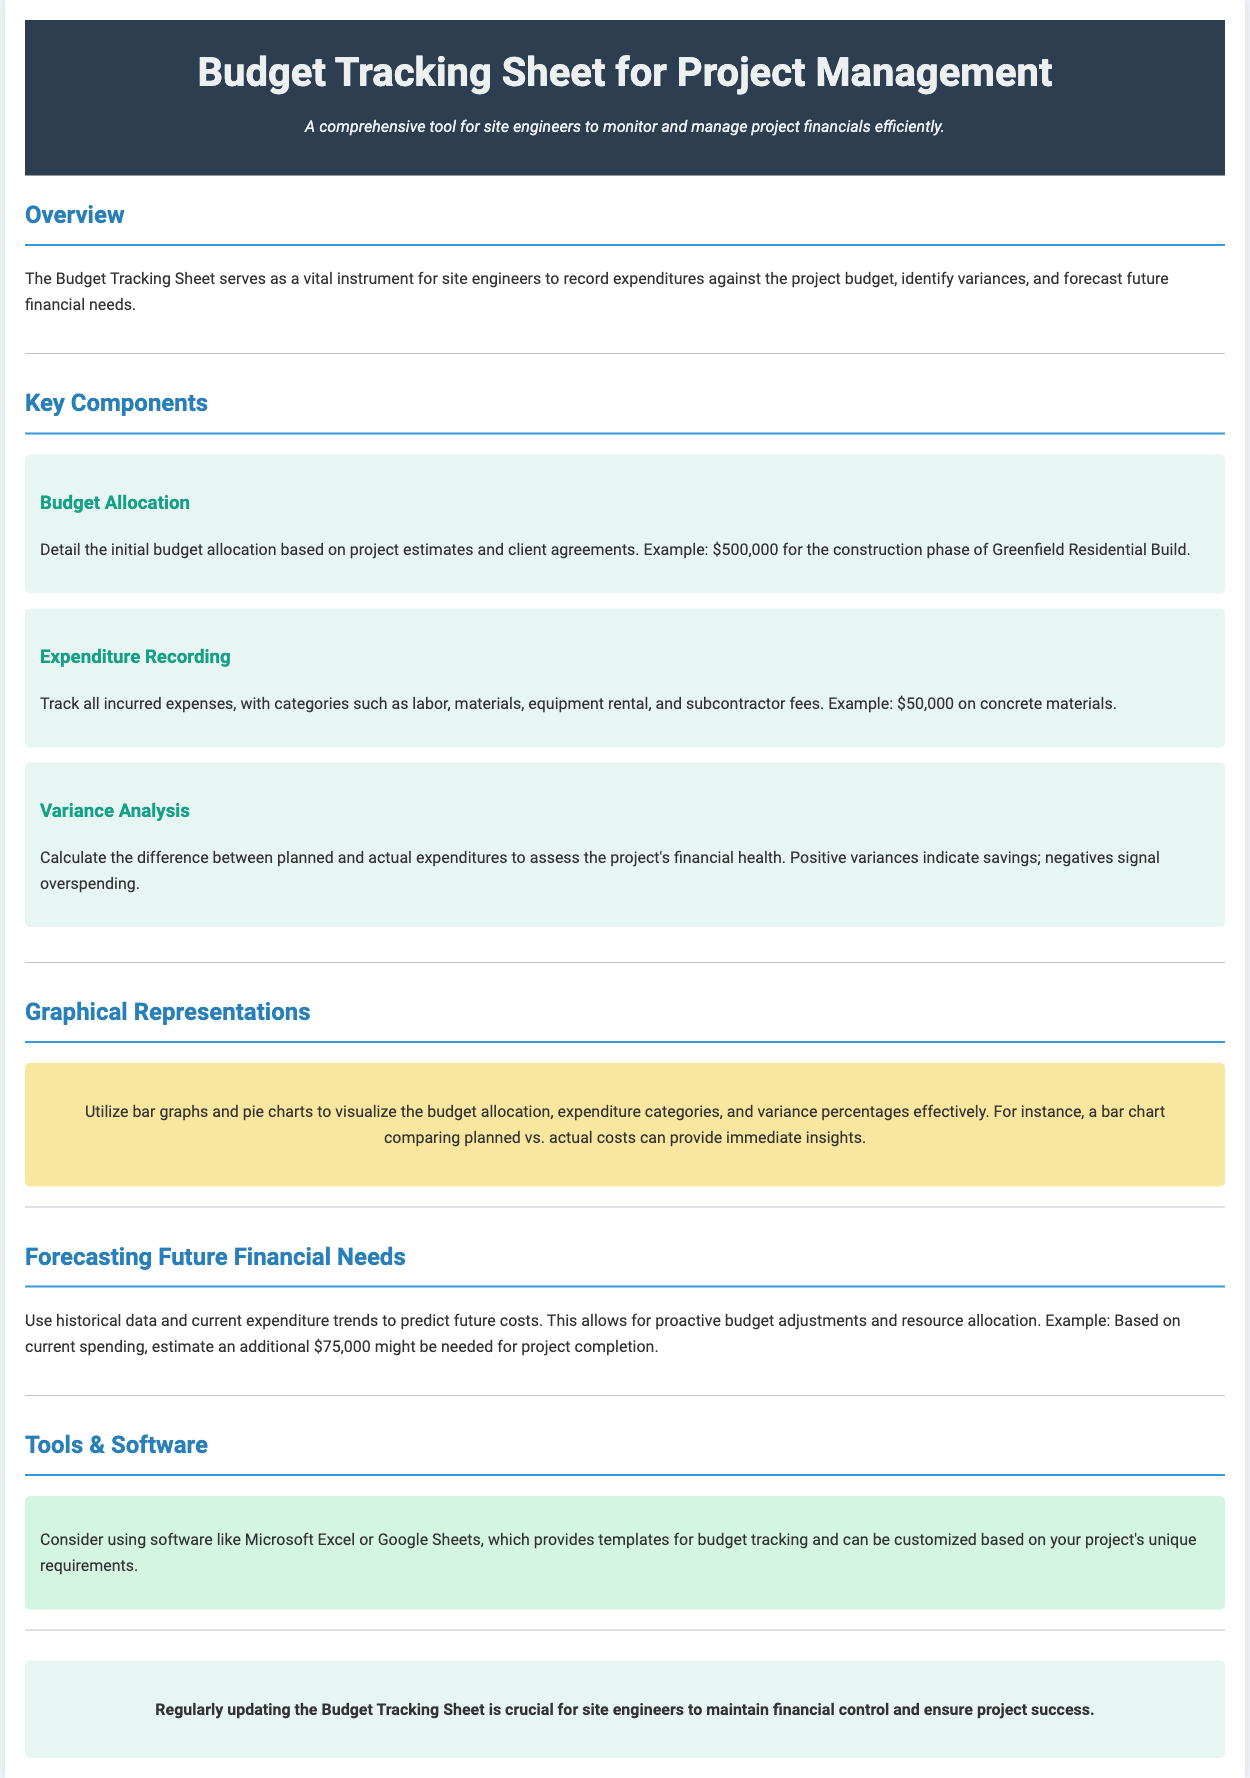What is the title of the document? The title is presented in the header of the document, clearly stated as "Budget Tracking Sheet for Project Management."
Answer: Budget Tracking Sheet for Project Management What is the initial budget allocation mentioned? The document provides an example of the initial budget allocation as $500,000 for the construction phase of a specific project.
Answer: $500,000 What type of expenses are tracked? Categories for tracking expenses include labor, materials, equipment rental, and subcontractor fees, which are detailed in the Expenditure Recording section.
Answer: Labor, materials, equipment rental, subcontractor fees What is indicated by positive variances in variance analysis? The document explains that positive variances indicate savings in the financial analysis.
Answer: Savings Which software is suggested for budget tracking? The document mentions using Microsoft Excel or Google Sheets as suggestions for budget tracking tools.
Answer: Microsoft Excel or Google Sheets What is the estimated additional amount needed for project completion? Based on current spending, the document forecasts an additional $75,000 may be required for project completion.
Answer: $75,000 What visual tools are recommended for representing budget data? The document advises using bar graphs and pie charts to visualize the budget allocation and expenditure categories effectively.
Answer: Bar graphs and pie charts Why is regular updating of the Budget Tracking Sheet important? The conclusion emphasizes that regularly updating the sheet is crucial for maintaining financial control and ensuring project success.
Answer: Financial control and project success 